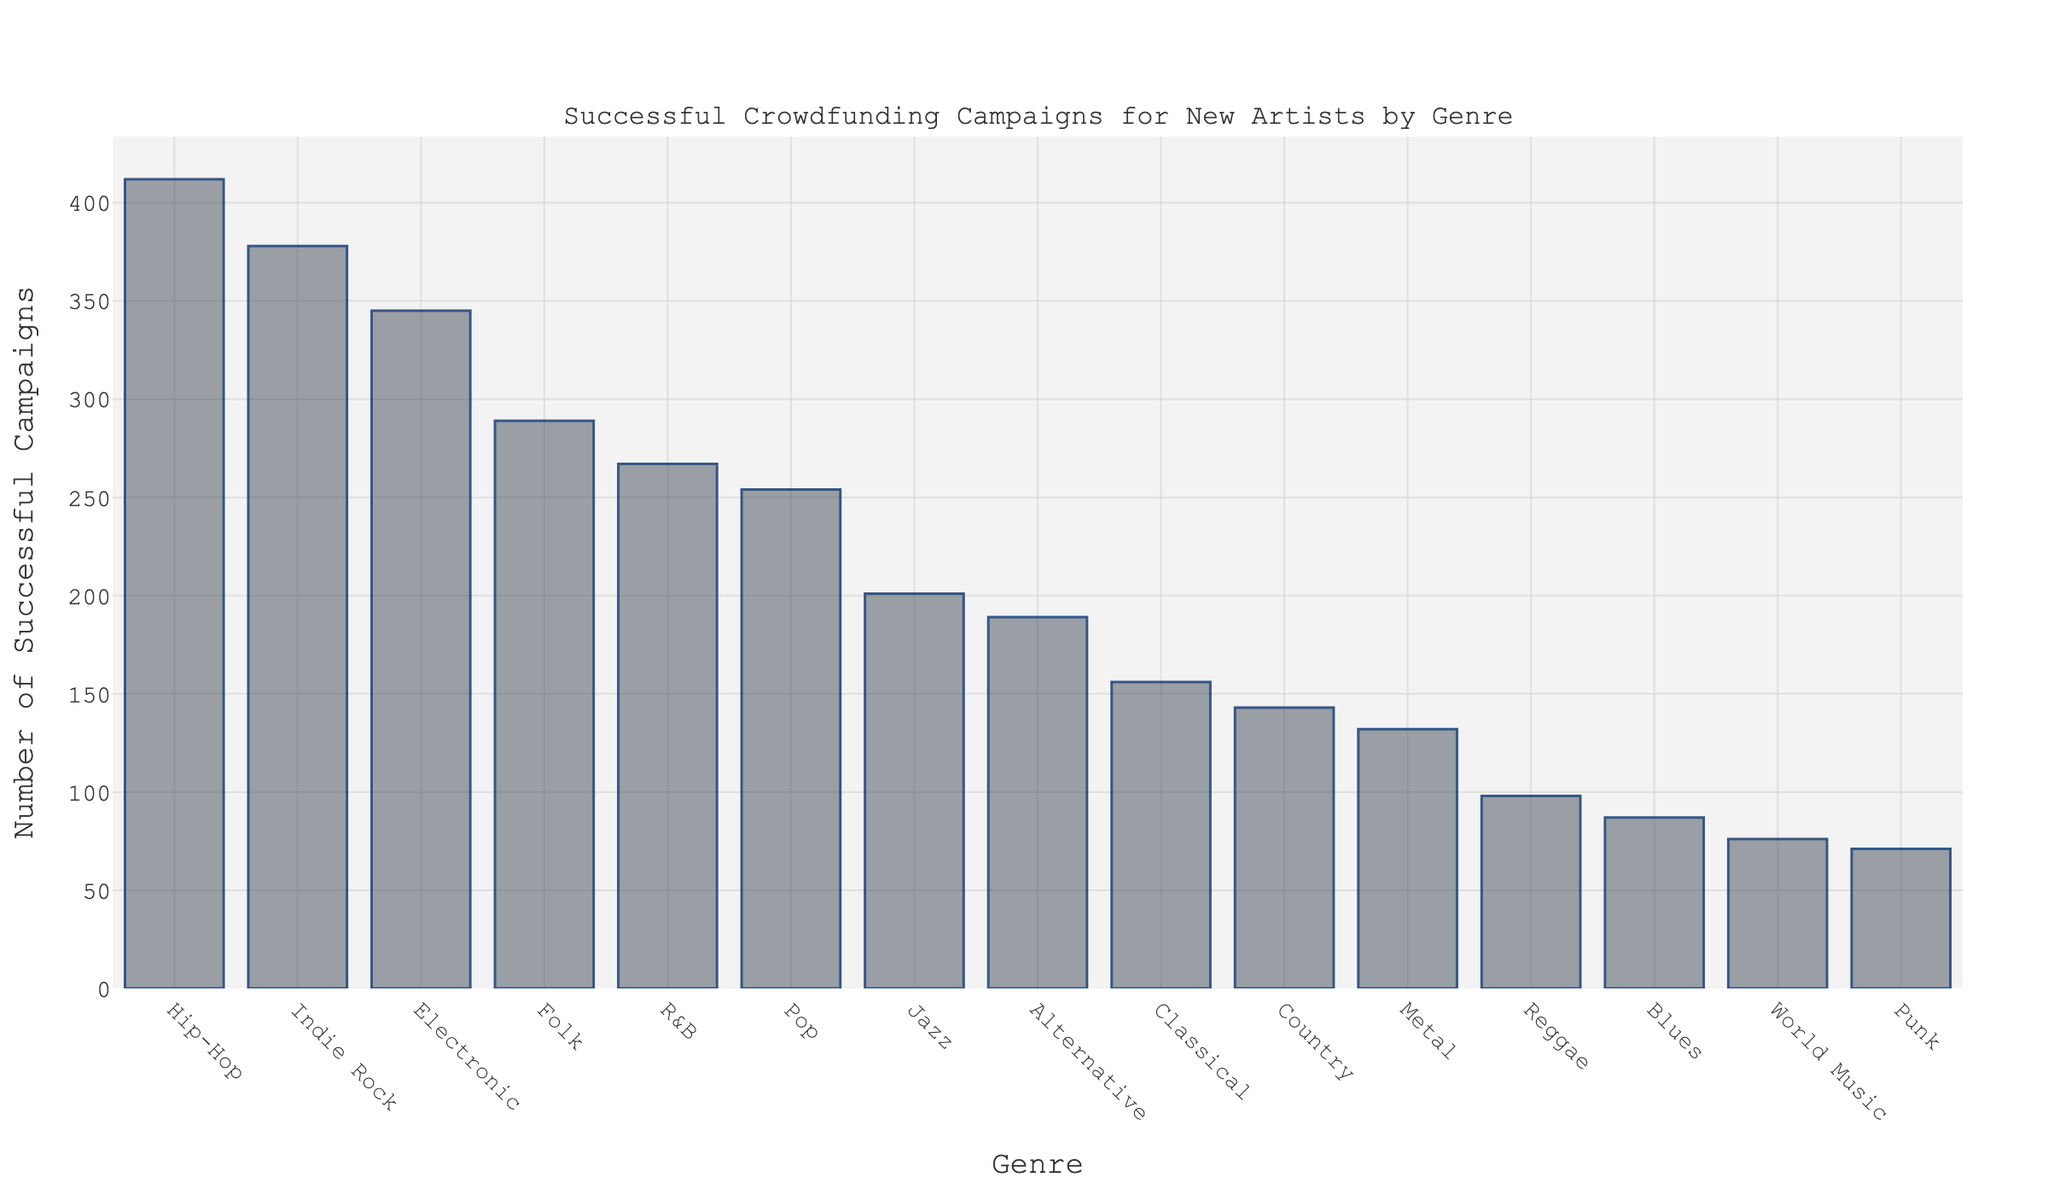Which genre has the highest number of successful crowdfunding campaigns? To find the genre with the highest number of successful crowdfunding campaigns, look at the bar with the greatest height. The tallest bar represents Hip-Hop.
Answer: Hip-Hop Which genre has fewer successful campaigns, Jazz or Reggae? Compare the heights of the bars for Jazz and Reggae. Jazz has a taller bar with 201 campaigns, while Reggae has 98 campaigns.
Answer: Reggae What is the combined number of successful campaigns for Folk and Pop? Look at the bars for Folk and Pop. Folk has 289 campaigns, and Pop has 254 campaigns. Adding them together: 289 + 254 = 543.
Answer: 543 Which genre has the least number of successful campaigns? To find the genre with the least number of successful campaigns, look for the shortest bar. The shortest bar represents Punk.
Answer: Punk How many more successful campaigns does Indie Rock have compared to Metal? Indie Rock has 378 campaigns, and Metal has 132 campaigns. Subtract the smaller number from the larger number: 378 - 132 = 246.
Answer: 246 What is the average number of successful campaigns across all genres? Sum the number of successful campaigns for all genres and divide by the total number of genres (15). The sum is 345.666 + 934.57 + ... + 71. Taking the total sum and dividing by 15 gives the average.
Answer: 208.93 Is the number of successful campaigns for Electronic greater than the combined total of Reggae and Blues? Electronic has 345 campaigns. Reggae has 98 campaigns, and Blues has 87 campaigns. The combined total of Reggae and Blues is 98 + 87 = 185. Since 345 is greater than 185, Electronic has more campaigns.
Answer: Yes Which has more successful campaigns: R&B or Classical? Compare the heights of the bars for R&B and Classical. R&B has 267 campaigns, and Classical has 156 campaigns.
Answer: R&B What is the difference between the number of successful campaigns for Hip-Hop and Jazz? Hip-Hop has 412 campaigns, and Jazz has 201 campaigns. Subtract the smaller number from the larger number: 412 - 201 = 211.
Answer: 211 What’s the total number of successful campaigns for genres with fewer than 200 campaigns? Add the number of successful campaigns for genres with fewer than 200 campaigns: Alternative (189), Classical (156), Country (143), Metal (132), Reggae (98), Blues (87), World Music (76), and Punk (71). The sum is 189 + 156 + 143 + 132 + 98 + 87 + 76 + 71 = 952.
Answer: 952 